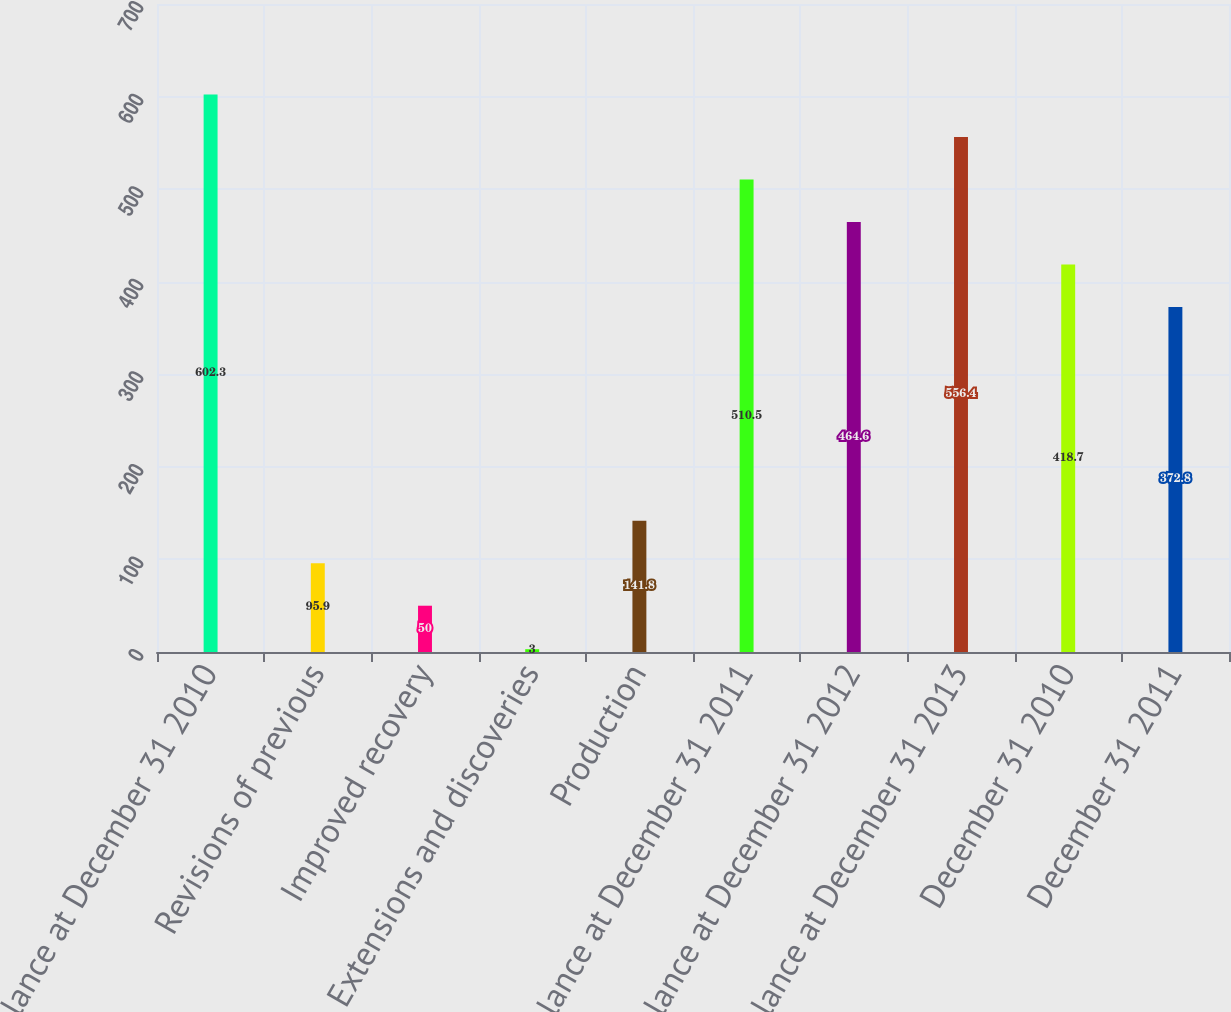Convert chart to OTSL. <chart><loc_0><loc_0><loc_500><loc_500><bar_chart><fcel>Balance at December 31 2010<fcel>Revisions of previous<fcel>Improved recovery<fcel>Extensions and discoveries<fcel>Production<fcel>Balance at December 31 2011<fcel>Balance at December 31 2012<fcel>Balance at December 31 2013<fcel>December 31 2010<fcel>December 31 2011<nl><fcel>602.3<fcel>95.9<fcel>50<fcel>3<fcel>141.8<fcel>510.5<fcel>464.6<fcel>556.4<fcel>418.7<fcel>372.8<nl></chart> 